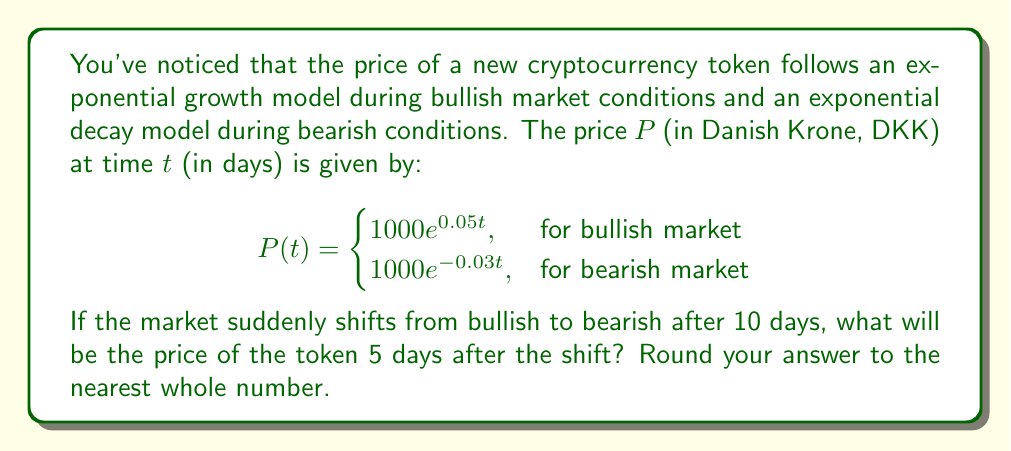Show me your answer to this math problem. Let's approach this problem step by step:

1) First, we need to calculate the price after 10 days of bullish market conditions.
   Using the bullish market equation:
   $$P(10) = 1000e^{0.05(10)} = 1000e^{0.5} \approx 1648.72 \text{ DKK}$$

2) This price (1648.72 DKK) becomes our new starting point for the bearish market conditions.

3) Now, we need to calculate the price after 5 more days of bearish market conditions.
   We'll use the bearish market equation, but with our new starting price:
   $$P(5) = 1648.72e^{-0.03(5)}$$

4) Let's solve this:
   $$P(5) = 1648.72e^{-0.15} \approx 1648.72 \cdot 0.8607 \approx 1419.05 \text{ DKK}$$

5) Rounding to the nearest whole number:
   1419.05 ≈ 1419 DKK
Answer: 1419 DKK 